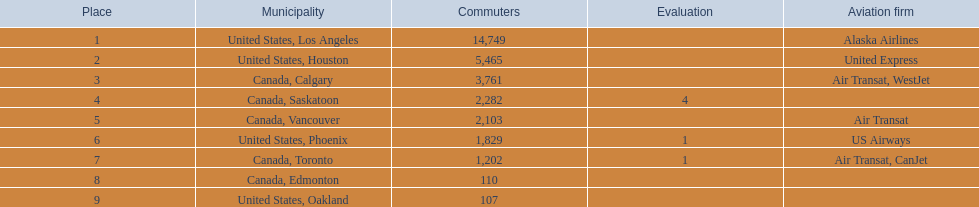What were all the passenger totals? 14,749, 5,465, 3,761, 2,282, 2,103, 1,829, 1,202, 110, 107. Would you mind parsing the complete table? {'header': ['Place', 'Municipality', 'Commuters', 'Evaluation', 'Aviation firm'], 'rows': [['1', 'United States, Los Angeles', '14,749', '', 'Alaska Airlines'], ['2', 'United States, Houston', '5,465', '', 'United Express'], ['3', 'Canada, Calgary', '3,761', '', 'Air Transat, WestJet'], ['4', 'Canada, Saskatoon', '2,282', '4', ''], ['5', 'Canada, Vancouver', '2,103', '', 'Air Transat'], ['6', 'United States, Phoenix', '1,829', '1', 'US Airways'], ['7', 'Canada, Toronto', '1,202', '1', 'Air Transat, CanJet'], ['8', 'Canada, Edmonton', '110', '', ''], ['9', 'United States, Oakland', '107', '', '']]} Which of these were to los angeles? 14,749. What other destination combined with this is closest to 19,000? Canada, Calgary. 